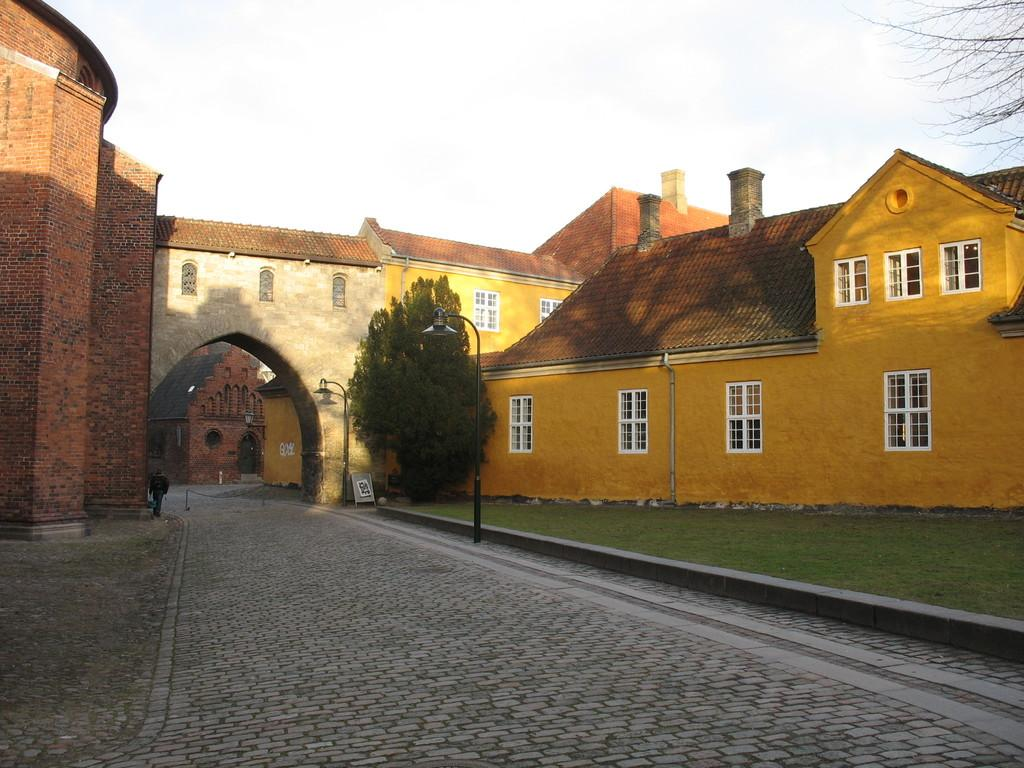What type of structures can be seen in the image? There are houses in the image. What other natural elements are present in the image? There are trees in the image. Can you describe the person in the image? There is a person in the image. What are the poles used for in the image? The purpose of the poles is not specified, but they are visible in the image. What other objects can be seen in the image? There are other objects in the image, but their specific details are not mentioned. What part of the ground is visible in the image? The floor is visible at the bottom of the image. What part of the sky is visible in the image? The sky is visible at the top of the image. What type of silk is being used to make the yam in the image? There is no silk or yam present in the image. Can you describe the stranger in the image? There is no stranger present in the image. 